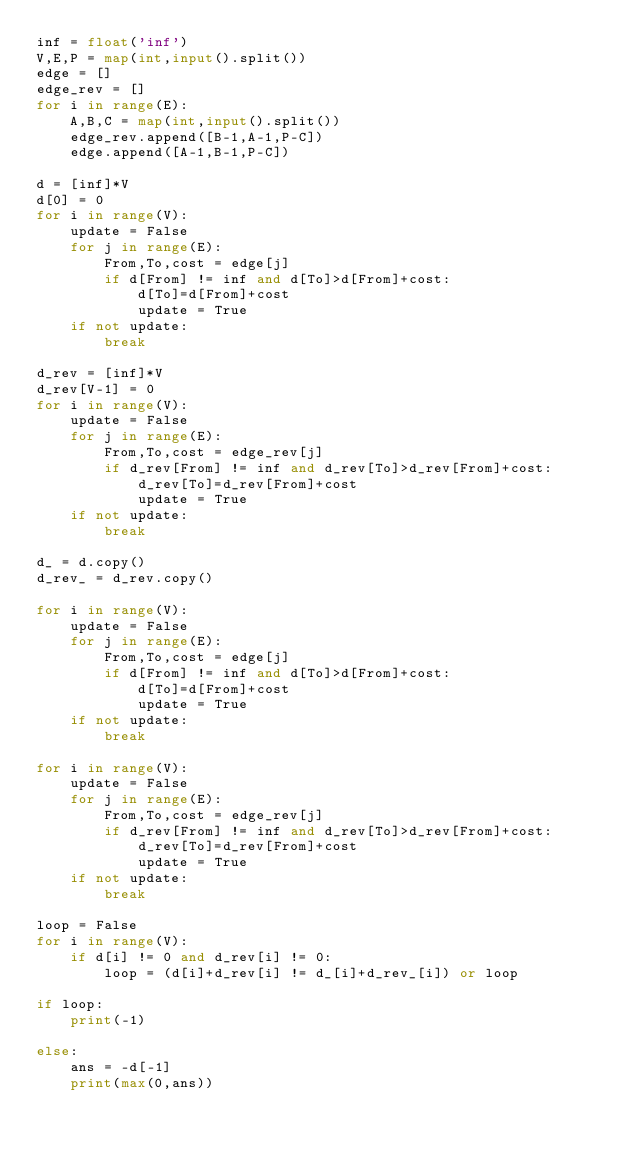Convert code to text. <code><loc_0><loc_0><loc_500><loc_500><_Python_>inf = float('inf')
V,E,P = map(int,input().split())
edge = []
edge_rev = []
for i in range(E):
    A,B,C = map(int,input().split())
    edge_rev.append([B-1,A-1,P-C])
    edge.append([A-1,B-1,P-C])

d = [inf]*V
d[0] = 0
for i in range(V):
    update = False
    for j in range(E):
        From,To,cost = edge[j]
        if d[From] != inf and d[To]>d[From]+cost:
            d[To]=d[From]+cost
            update = True
    if not update:
        break

d_rev = [inf]*V
d_rev[V-1] = 0
for i in range(V):
    update = False
    for j in range(E):
        From,To,cost = edge_rev[j]
        if d_rev[From] != inf and d_rev[To]>d_rev[From]+cost:
            d_rev[To]=d_rev[From]+cost
            update = True
    if not update:
        break

d_ = d.copy()
d_rev_ = d_rev.copy()

for i in range(V):
    update = False
    for j in range(E):
        From,To,cost = edge[j]
        if d[From] != inf and d[To]>d[From]+cost:
            d[To]=d[From]+cost
            update = True
    if not update:
        break

for i in range(V):
    update = False
    for j in range(E):
        From,To,cost = edge_rev[j]
        if d_rev[From] != inf and d_rev[To]>d_rev[From]+cost:
            d_rev[To]=d_rev[From]+cost
            update = True
    if not update:
        break

loop = False
for i in range(V):
    if d[i] != 0 and d_rev[i] != 0:
        loop = (d[i]+d_rev[i] != d_[i]+d_rev_[i]) or loop

if loop:
    print(-1)

else:
    ans = -d[-1]
    print(max(0,ans))</code> 